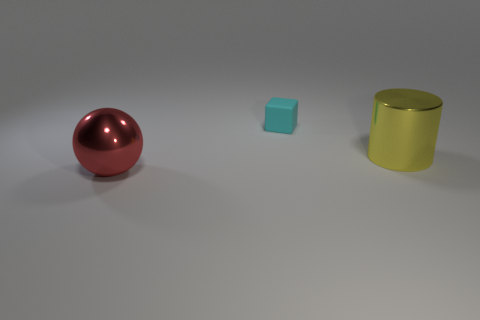Add 2 big yellow shiny blocks. How many objects exist? 5 Subtract all blocks. How many objects are left? 2 Add 3 large metal objects. How many large metal objects are left? 5 Add 3 big yellow cylinders. How many big yellow cylinders exist? 4 Subtract 1 cyan blocks. How many objects are left? 2 Subtract 1 cylinders. How many cylinders are left? 0 Subtract all green spheres. Subtract all brown blocks. How many spheres are left? 1 Subtract all blue spheres. How many yellow cubes are left? 0 Subtract all cyan rubber cubes. Subtract all large yellow shiny objects. How many objects are left? 1 